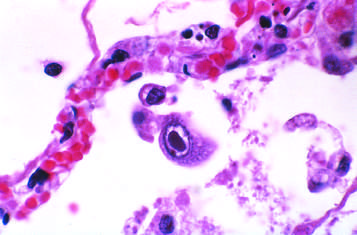what do infected cells show?
Answer the question using a single word or phrase. Distinct nuclear and ill-defined cytoplasmic 